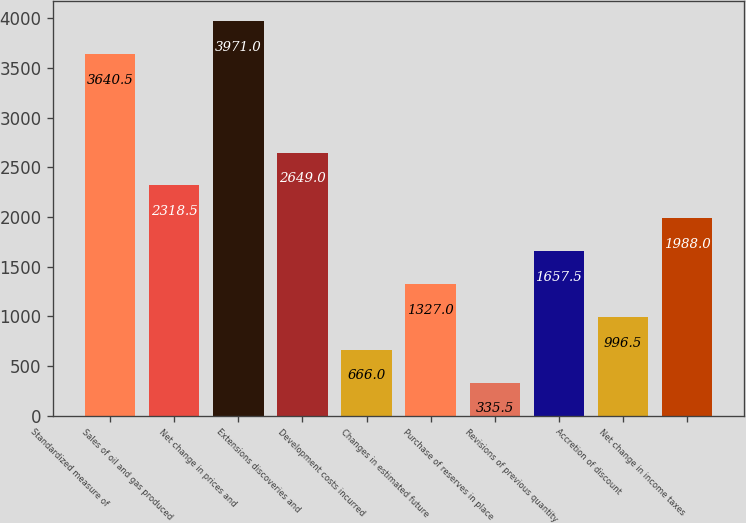Convert chart to OTSL. <chart><loc_0><loc_0><loc_500><loc_500><bar_chart><fcel>Standardized measure of<fcel>Sales of oil and gas produced<fcel>Net change in prices and<fcel>Extensions discoveries and<fcel>Development costs incurred<fcel>Changes in estimated future<fcel>Purchase of reserves in place<fcel>Revisions of previous quantity<fcel>Accretion of discount<fcel>Net change in income taxes<nl><fcel>3640.5<fcel>2318.5<fcel>3971<fcel>2649<fcel>666<fcel>1327<fcel>335.5<fcel>1657.5<fcel>996.5<fcel>1988<nl></chart> 